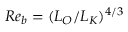<formula> <loc_0><loc_0><loc_500><loc_500>R e _ { b } = ( L _ { O } / L _ { K } ) ^ { 4 / 3 }</formula> 